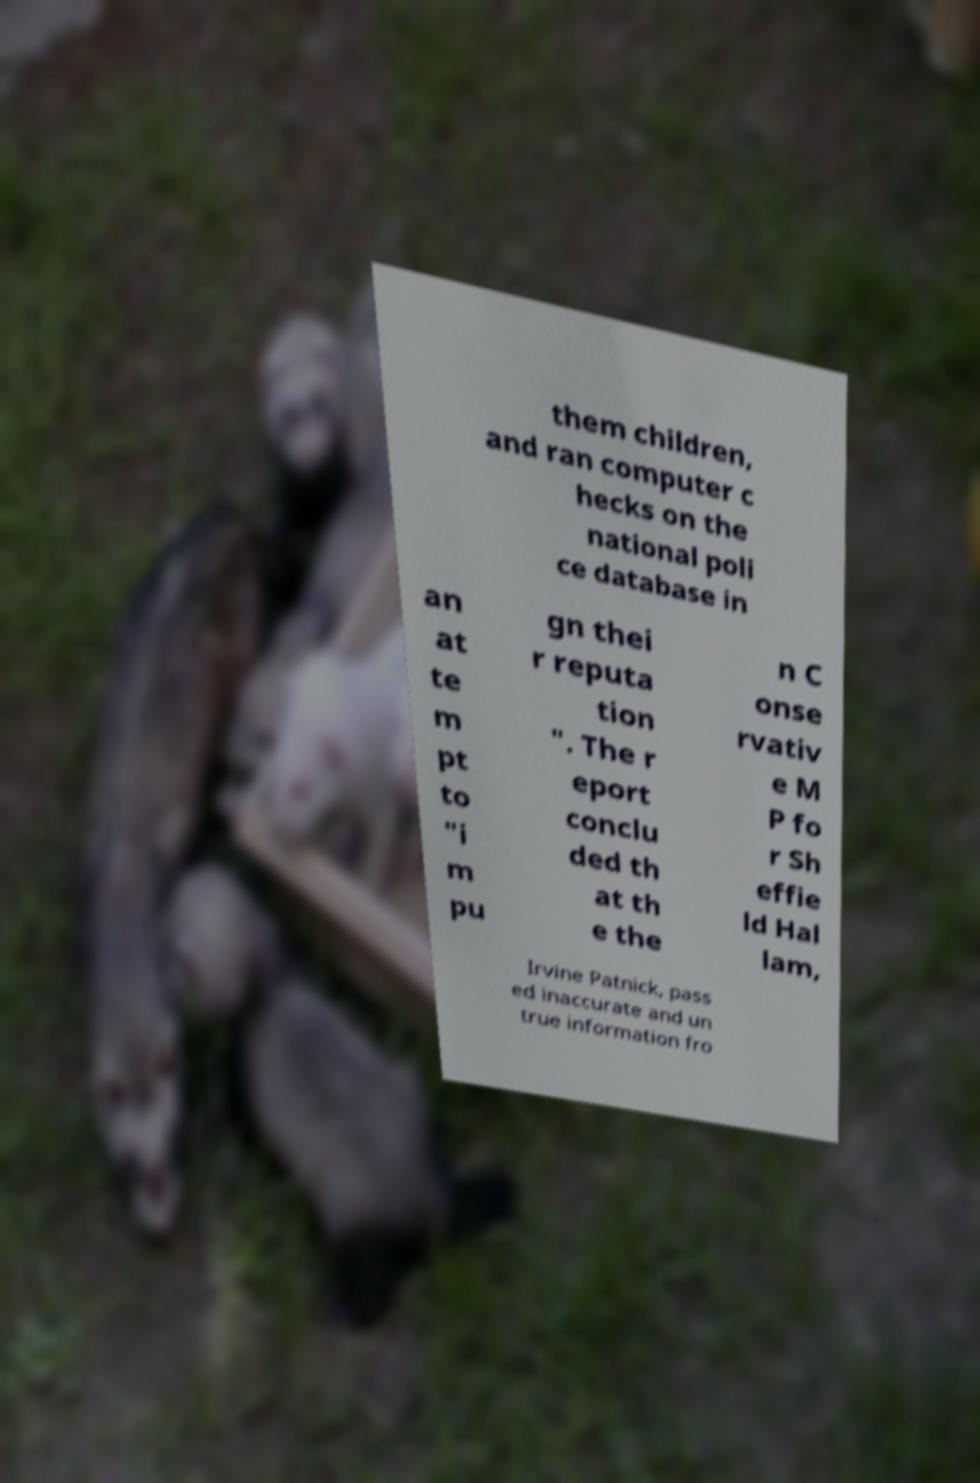Can you read and provide the text displayed in the image?This photo seems to have some interesting text. Can you extract and type it out for me? them children, and ran computer c hecks on the national poli ce database in an at te m pt to "i m pu gn thei r reputa tion ". The r eport conclu ded th at th e the n C onse rvativ e M P fo r Sh effie ld Hal lam, Irvine Patnick, pass ed inaccurate and un true information fro 